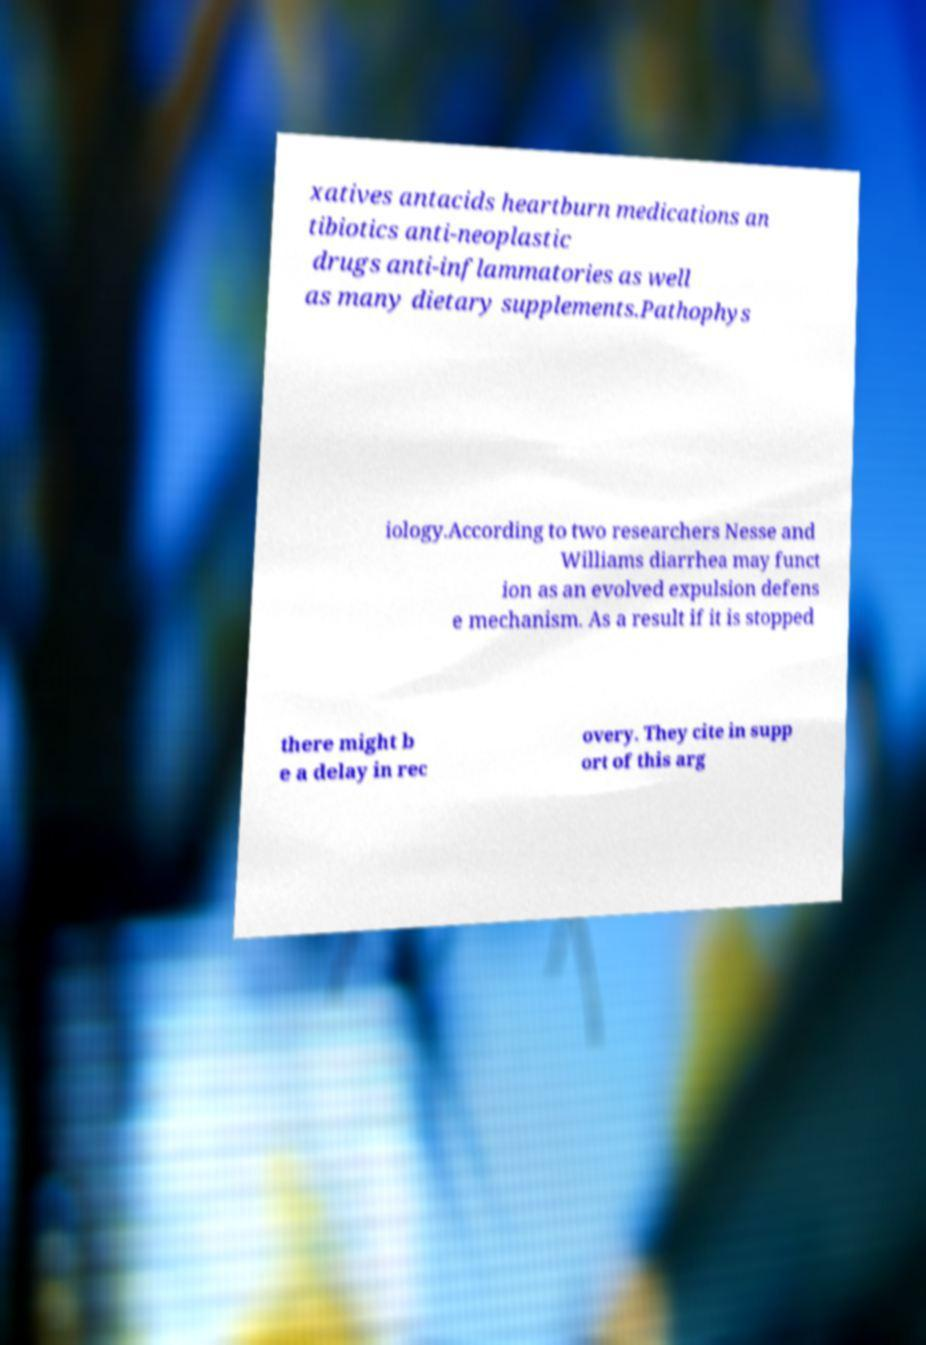What messages or text are displayed in this image? I need them in a readable, typed format. xatives antacids heartburn medications an tibiotics anti-neoplastic drugs anti-inflammatories as well as many dietary supplements.Pathophys iology.According to two researchers Nesse and Williams diarrhea may funct ion as an evolved expulsion defens e mechanism. As a result if it is stopped there might b e a delay in rec overy. They cite in supp ort of this arg 